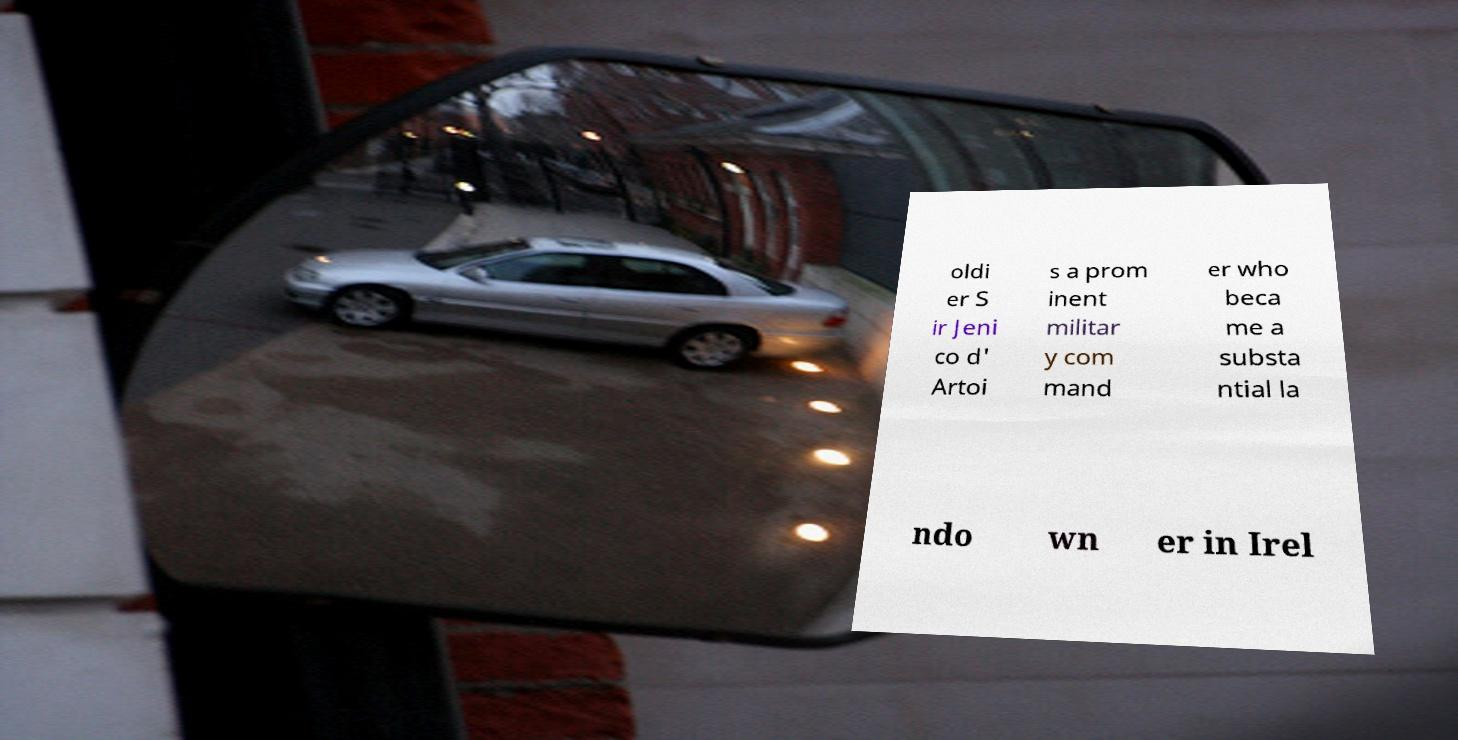There's text embedded in this image that I need extracted. Can you transcribe it verbatim? oldi er S ir Jeni co d' Artoi s a prom inent militar y com mand er who beca me a substa ntial la ndo wn er in Irel 